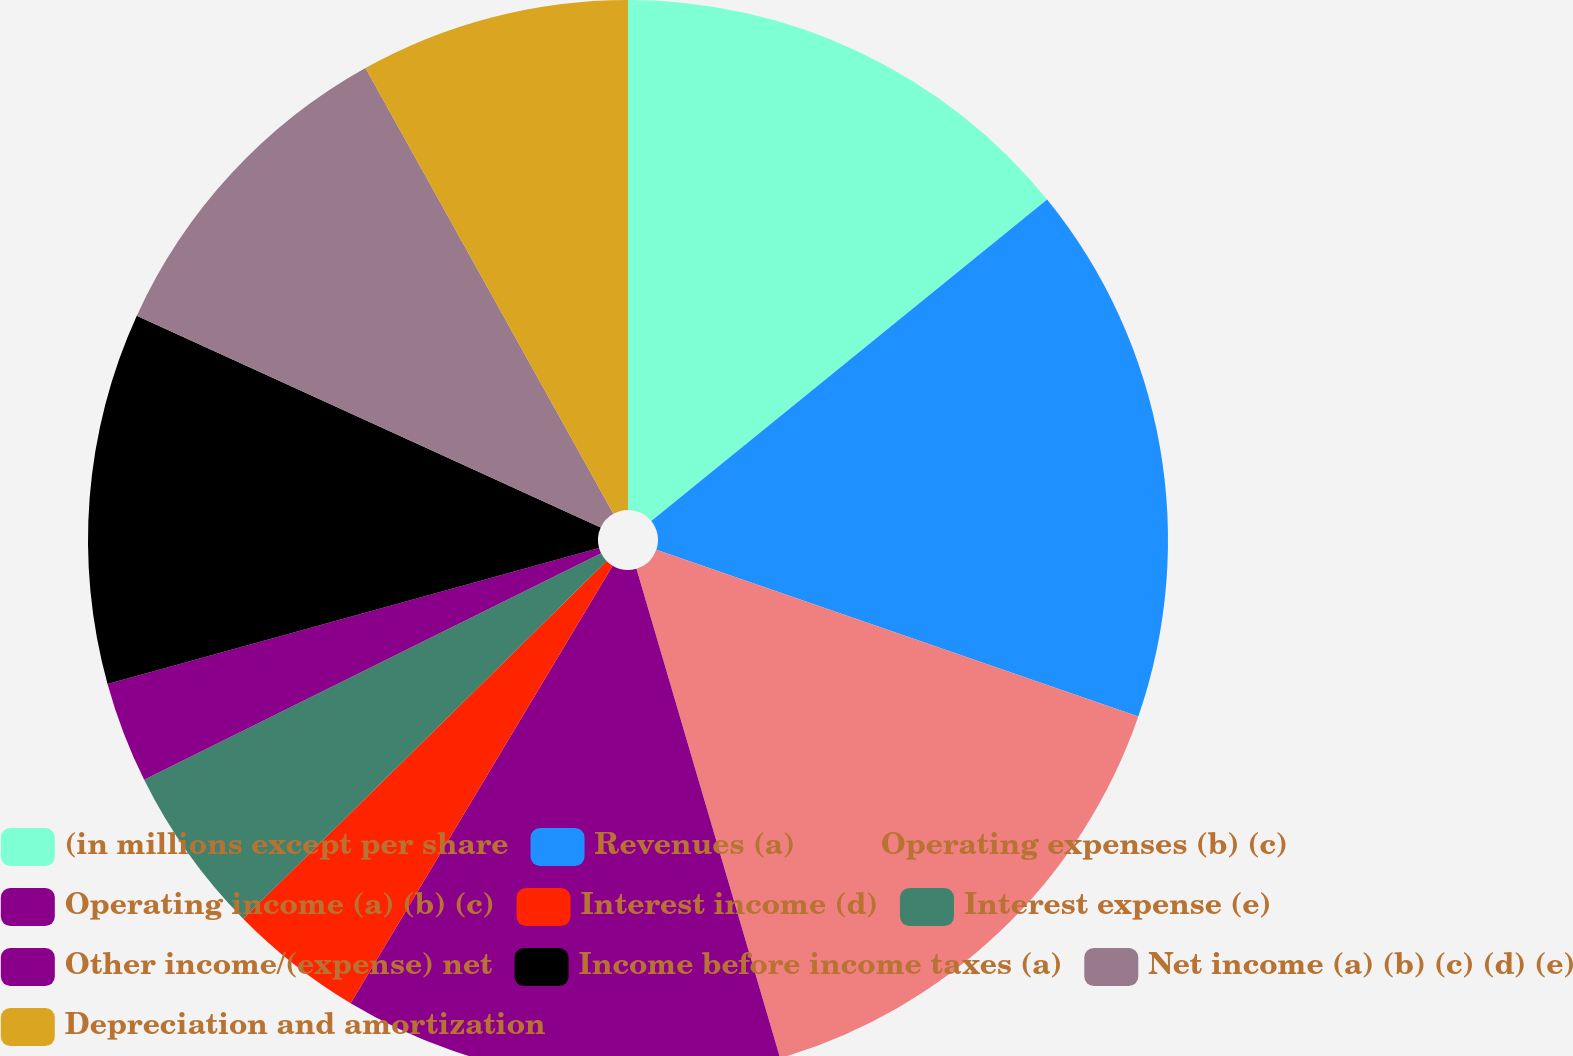Convert chart to OTSL. <chart><loc_0><loc_0><loc_500><loc_500><pie_chart><fcel>(in millions except per share<fcel>Revenues (a)<fcel>Operating expenses (b) (c)<fcel>Operating income (a) (b) (c)<fcel>Interest income (d)<fcel>Interest expense (e)<fcel>Other income/(expense) net<fcel>Income before income taxes (a)<fcel>Net income (a) (b) (c) (d) (e)<fcel>Depreciation and amortization<nl><fcel>14.14%<fcel>16.16%<fcel>15.15%<fcel>13.13%<fcel>4.04%<fcel>5.05%<fcel>3.03%<fcel>11.11%<fcel>10.1%<fcel>8.08%<nl></chart> 